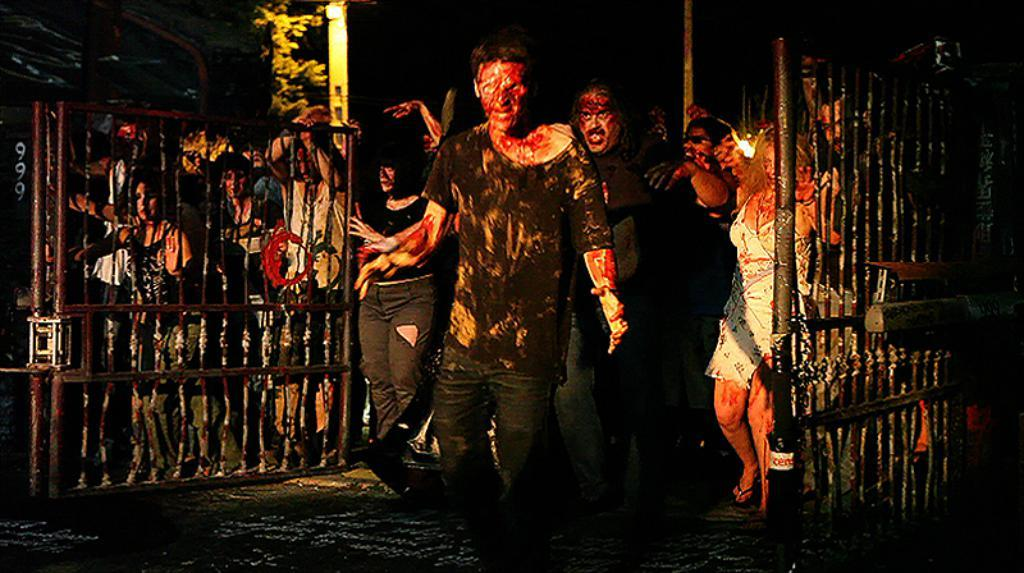What structure can be seen in the image? There is a gate in the image. What are the people in the image wearing? The people in the image are wearing different costumes. What type of plant is visible in the image? There is a tree in the image. What are the poles used for in the image? The purpose of the poles in the image is not specified, but they could be used for support or decoration. What type of illumination is present in the image? There is light in the image. How would you describe the overall lighting in the image? The background of the image is dark. Can you tell me how many owls are perched on the gate in the image? There are no owls present in the image; it features a gate, people in costumes, a tree, poles, light, and a dark background. What type of operation is being performed on the tree in the image? There is no operation being performed on the tree in the image; it is a static element in the scene. 